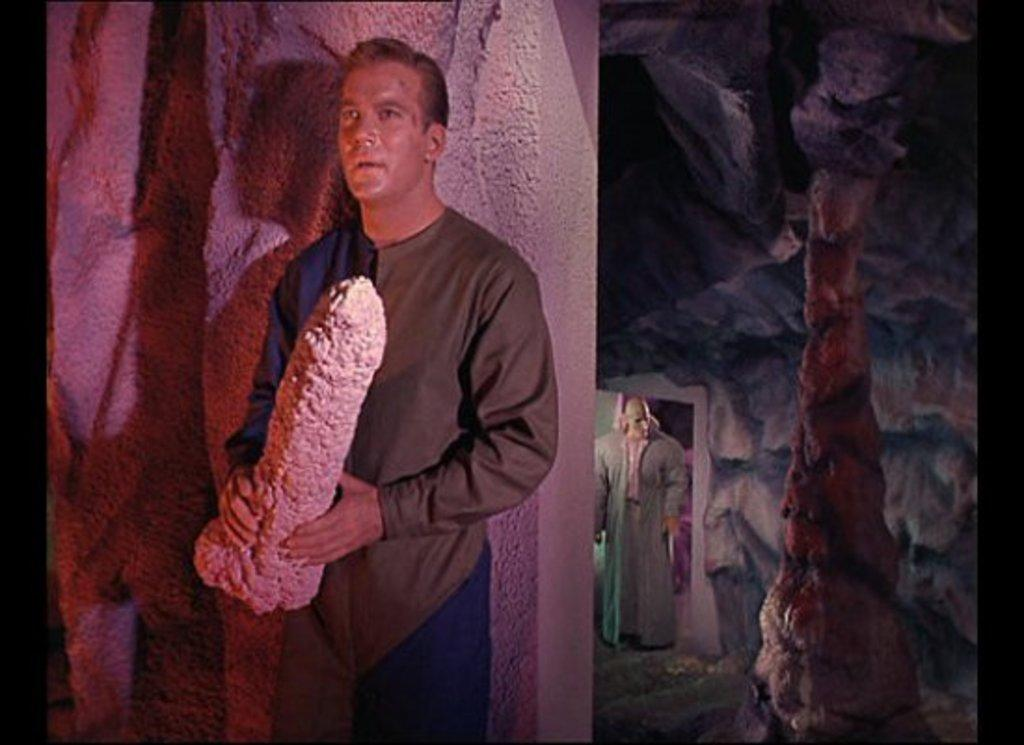What is the person in the image wearing? There is a person with a dress in the image. What is the person holding in the image? The person is holding an object. Can you describe the other person in the image? There is another person with a costume in the image. What can be seen to the right of the first person? There is a setting to the right of the first person. How does the person with the dress blow bubbles on the sidewalk in the image? There is no sidewalk or bubbles present in the image. 